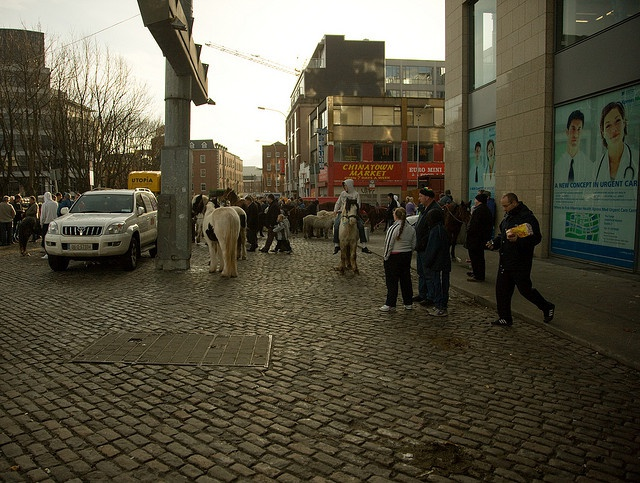Describe the objects in this image and their specific colors. I can see people in lightgray, black, darkgreen, and gray tones, car in lightgray, black, gray, darkgreen, and darkgray tones, people in lightgray, black, maroon, olive, and gray tones, people in lightgray, black, and gray tones, and horse in lightgray, gray, and black tones in this image. 